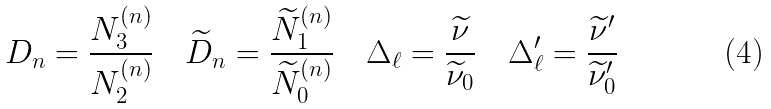Convert formula to latex. <formula><loc_0><loc_0><loc_500><loc_500>D _ { n } = \frac { N _ { 3 } ^ { ( n ) } } { N _ { 2 } ^ { ( n ) } } \quad \widetilde { D } _ { n } = \frac { \widetilde { N } _ { 1 } ^ { ( n ) } } { \widetilde { N } _ { 0 } ^ { ( n ) } } \quad \Delta _ { \ell } = \frac { \widetilde { \nu } } { \widetilde { \nu } _ { 0 } } \quad \Delta _ { \ell } ^ { \prime } = \frac { \widetilde { \nu } ^ { \prime } } { \widetilde { \nu } ^ { \prime } _ { 0 } }</formula> 